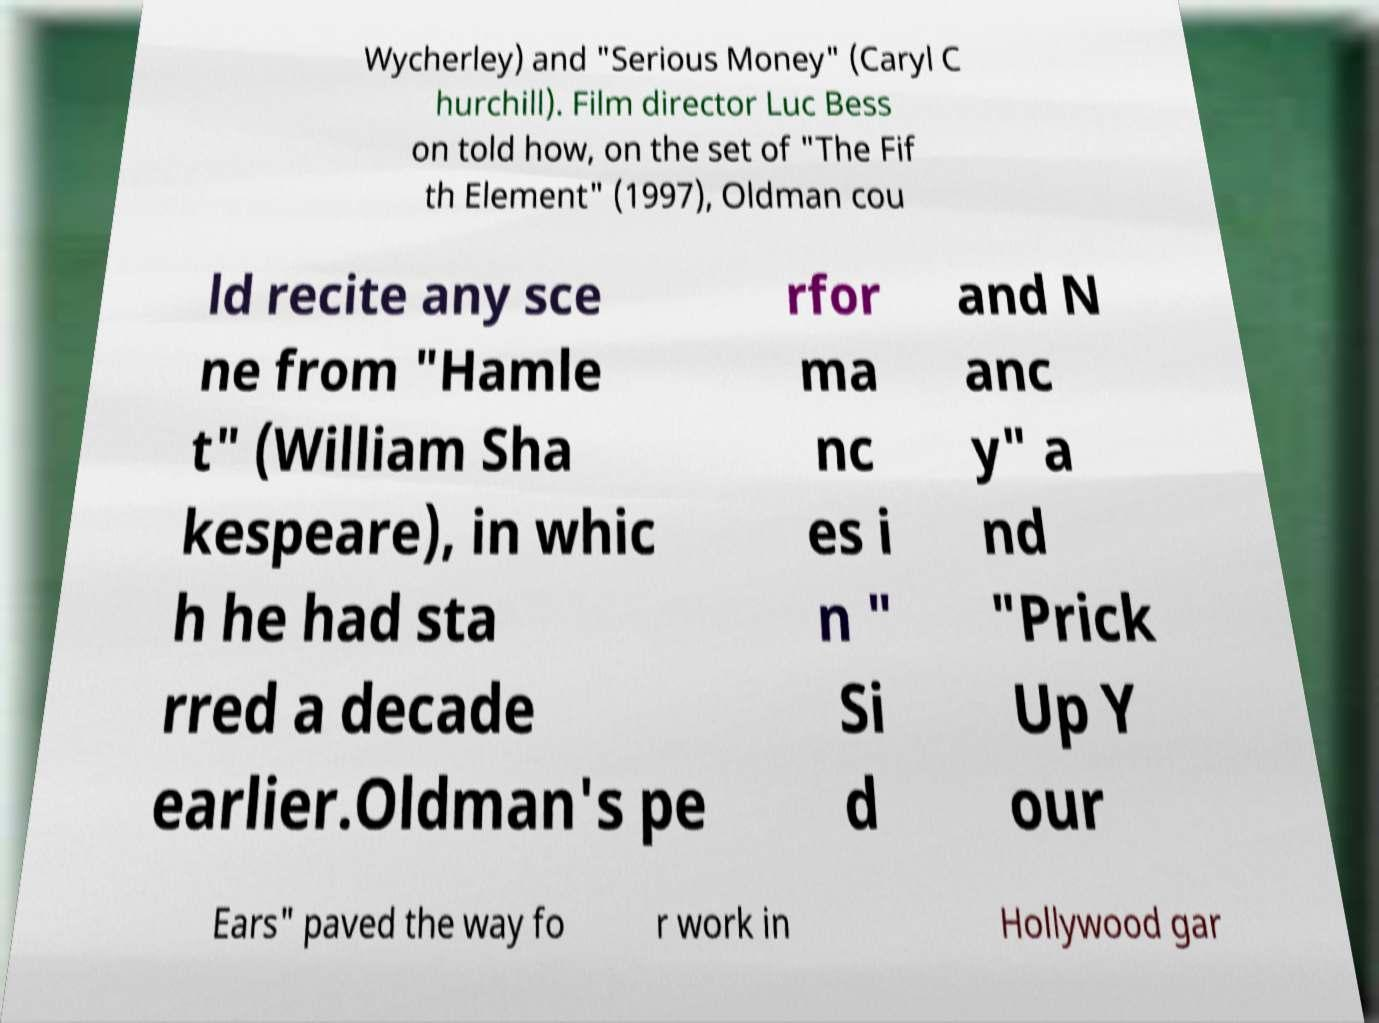For documentation purposes, I need the text within this image transcribed. Could you provide that? Wycherley) and "Serious Money" (Caryl C hurchill). Film director Luc Bess on told how, on the set of "The Fif th Element" (1997), Oldman cou ld recite any sce ne from "Hamle t" (William Sha kespeare), in whic h he had sta rred a decade earlier.Oldman's pe rfor ma nc es i n " Si d and N anc y" a nd "Prick Up Y our Ears" paved the way fo r work in Hollywood gar 